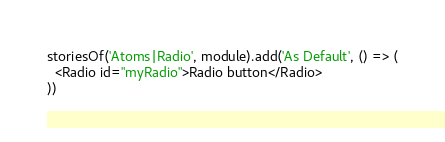Convert code to text. <code><loc_0><loc_0><loc_500><loc_500><_TypeScript_>storiesOf('Atoms|Radio', module).add('As Default', () => (
  <Radio id="myRadio">Radio button</Radio>
))
</code> 